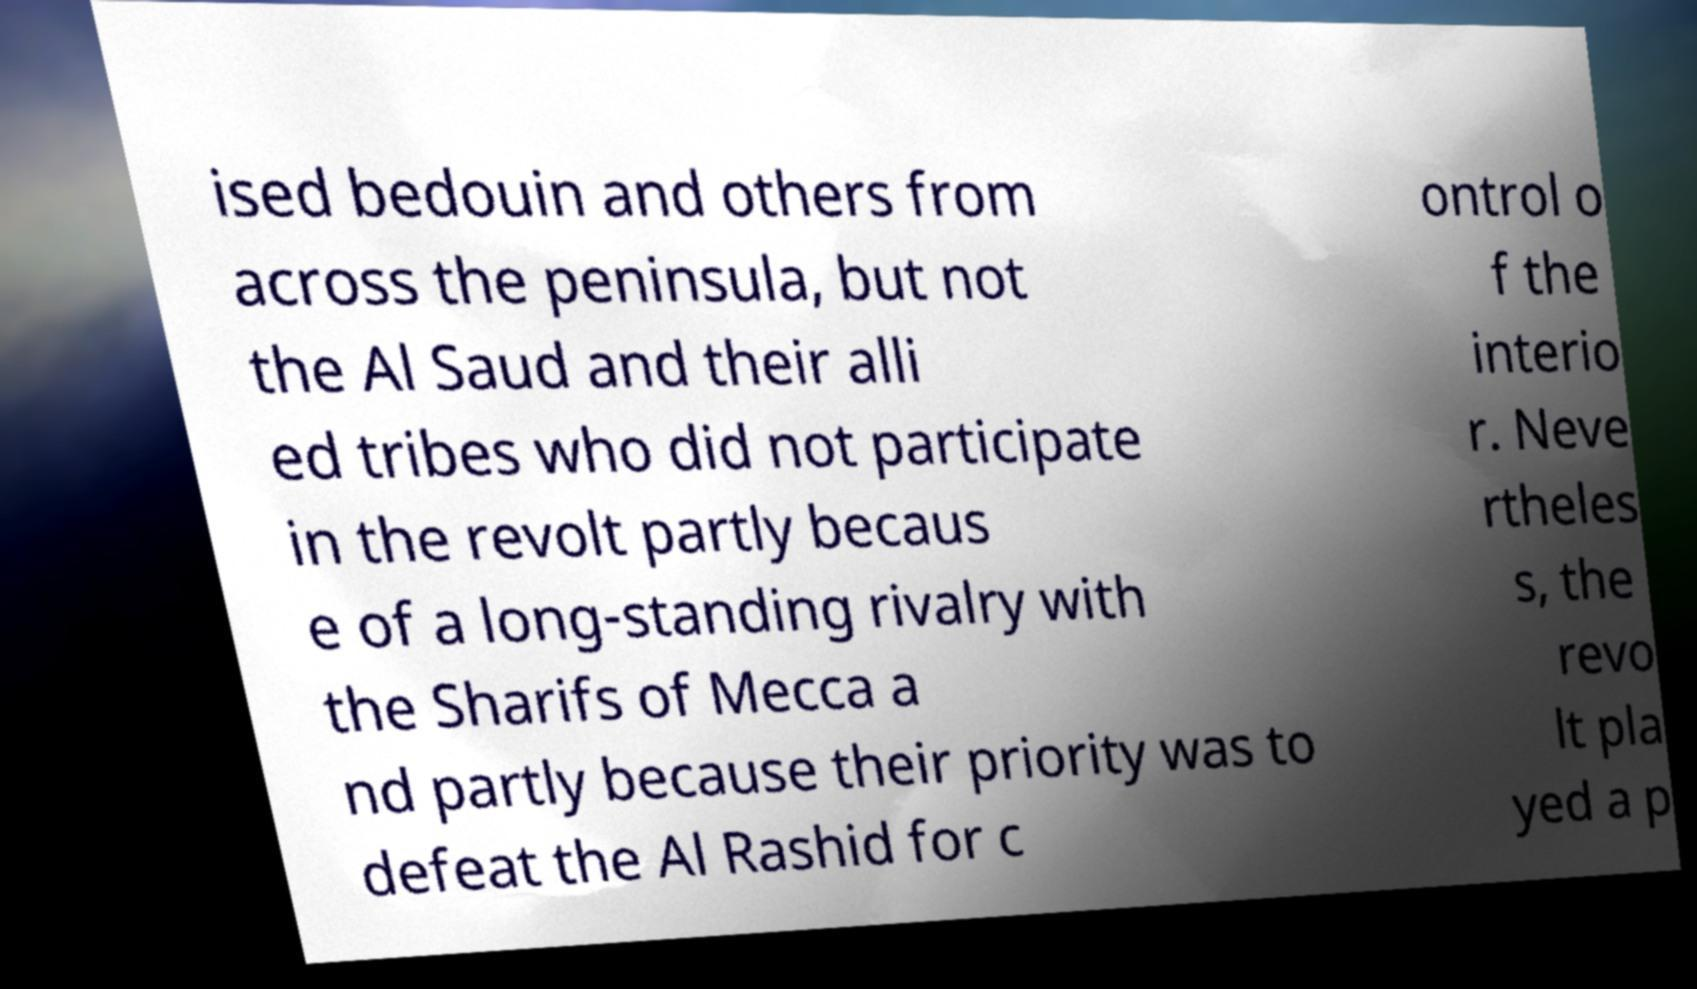Could you extract and type out the text from this image? ised bedouin and others from across the peninsula, but not the Al Saud and their alli ed tribes who did not participate in the revolt partly becaus e of a long-standing rivalry with the Sharifs of Mecca a nd partly because their priority was to defeat the Al Rashid for c ontrol o f the interio r. Neve rtheles s, the revo lt pla yed a p 